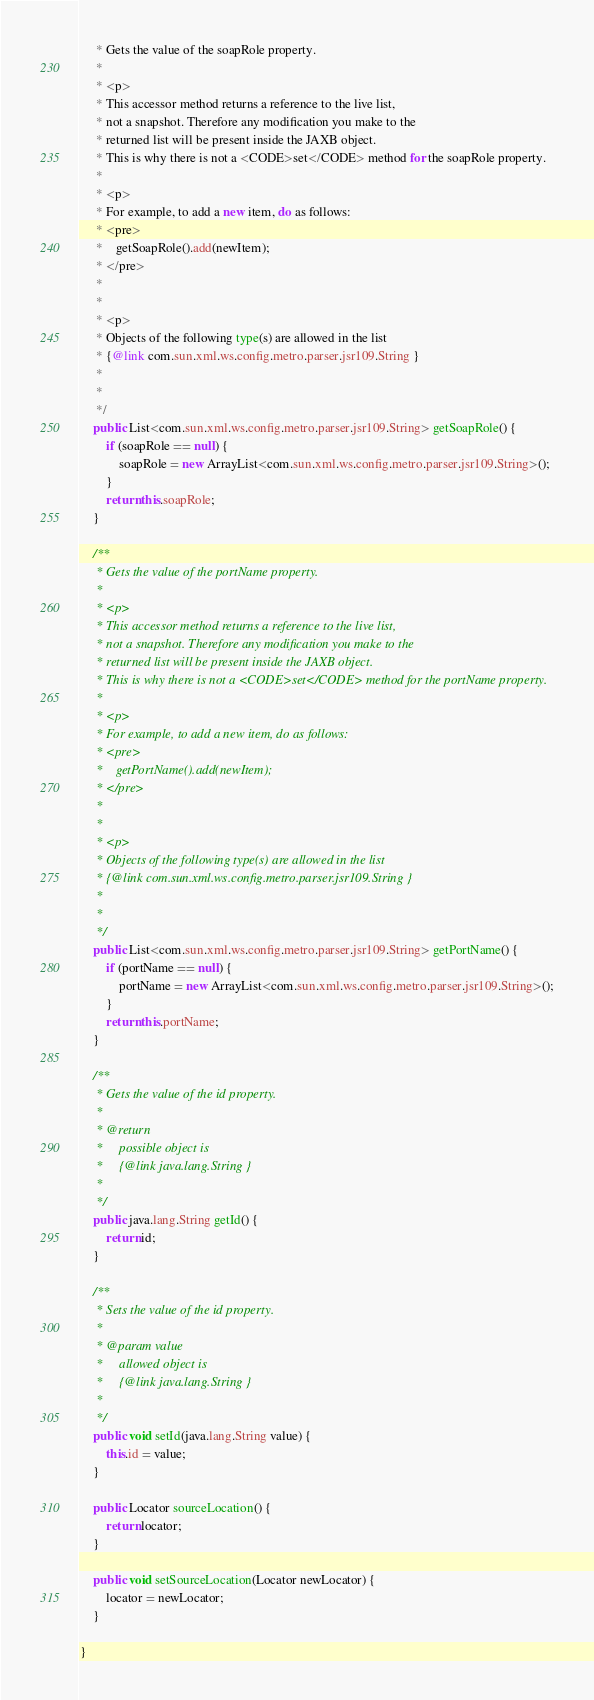<code> <loc_0><loc_0><loc_500><loc_500><_Java_>     * Gets the value of the soapRole property.
     * 
     * <p>
     * This accessor method returns a reference to the live list,
     * not a snapshot. Therefore any modification you make to the
     * returned list will be present inside the JAXB object.
     * This is why there is not a <CODE>set</CODE> method for the soapRole property.
     * 
     * <p>
     * For example, to add a new item, do as follows:
     * <pre>
     *    getSoapRole().add(newItem);
     * </pre>
     * 
     * 
     * <p>
     * Objects of the following type(s) are allowed in the list
     * {@link com.sun.xml.ws.config.metro.parser.jsr109.String }
     * 
     * 
     */
    public List<com.sun.xml.ws.config.metro.parser.jsr109.String> getSoapRole() {
        if (soapRole == null) {
            soapRole = new ArrayList<com.sun.xml.ws.config.metro.parser.jsr109.String>();
        }
        return this.soapRole;
    }

    /**
     * Gets the value of the portName property.
     * 
     * <p>
     * This accessor method returns a reference to the live list,
     * not a snapshot. Therefore any modification you make to the
     * returned list will be present inside the JAXB object.
     * This is why there is not a <CODE>set</CODE> method for the portName property.
     * 
     * <p>
     * For example, to add a new item, do as follows:
     * <pre>
     *    getPortName().add(newItem);
     * </pre>
     * 
     * 
     * <p>
     * Objects of the following type(s) are allowed in the list
     * {@link com.sun.xml.ws.config.metro.parser.jsr109.String }
     * 
     * 
     */
    public List<com.sun.xml.ws.config.metro.parser.jsr109.String> getPortName() {
        if (portName == null) {
            portName = new ArrayList<com.sun.xml.ws.config.metro.parser.jsr109.String>();
        }
        return this.portName;
    }

    /**
     * Gets the value of the id property.
     * 
     * @return
     *     possible object is
     *     {@link java.lang.String }
     *     
     */
    public java.lang.String getId() {
        return id;
    }

    /**
     * Sets the value of the id property.
     * 
     * @param value
     *     allowed object is
     *     {@link java.lang.String }
     *     
     */
    public void setId(java.lang.String value) {
        this.id = value;
    }

    public Locator sourceLocation() {
        return locator;
    }

    public void setSourceLocation(Locator newLocator) {
        locator = newLocator;
    }

}
</code> 